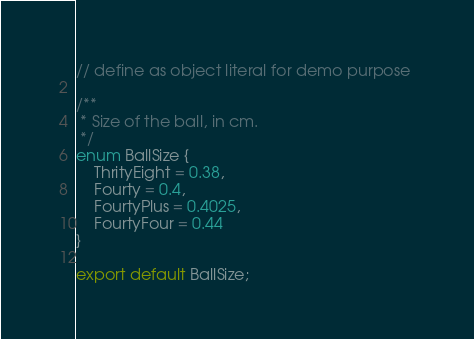<code> <loc_0><loc_0><loc_500><loc_500><_TypeScript_>// define as object literal for demo purpose 

/**
 * Size of the ball, in cm.
 */
enum BallSize {
	ThrityEight = 0.38,
	Fourty = 0.4,
	FourtyPlus = 0.4025,
	FourtyFour = 0.44
}

export default BallSize;</code> 